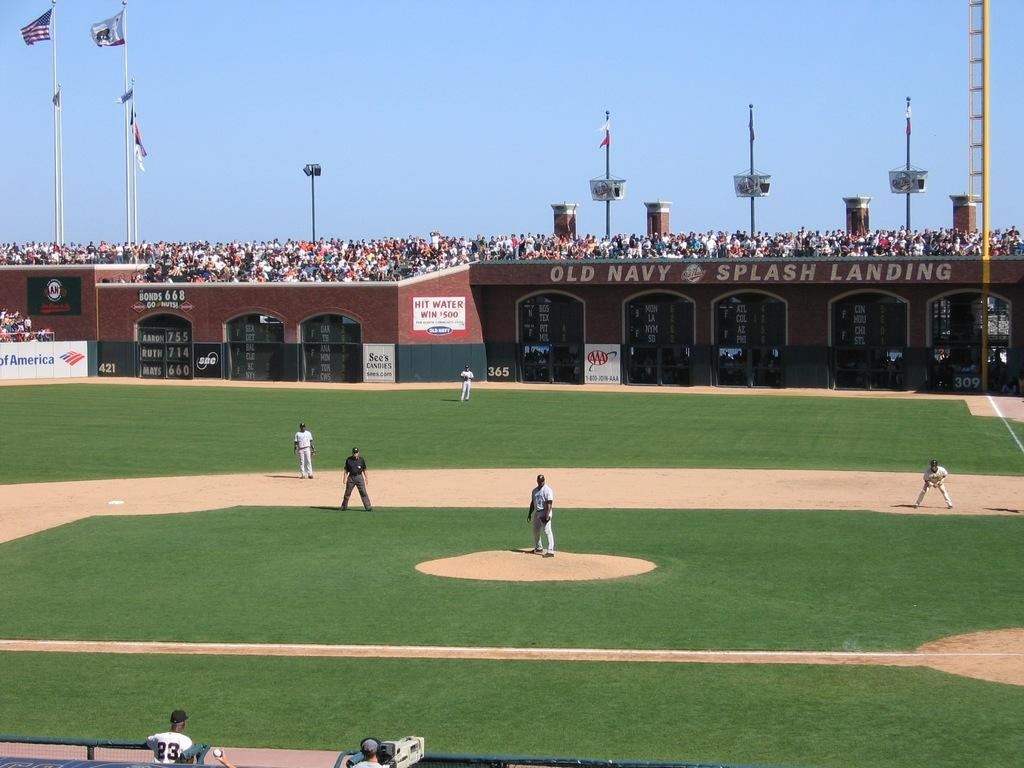<image>
Give a short and clear explanation of the subsequent image. Old Navy is advertised in a baseball field. 